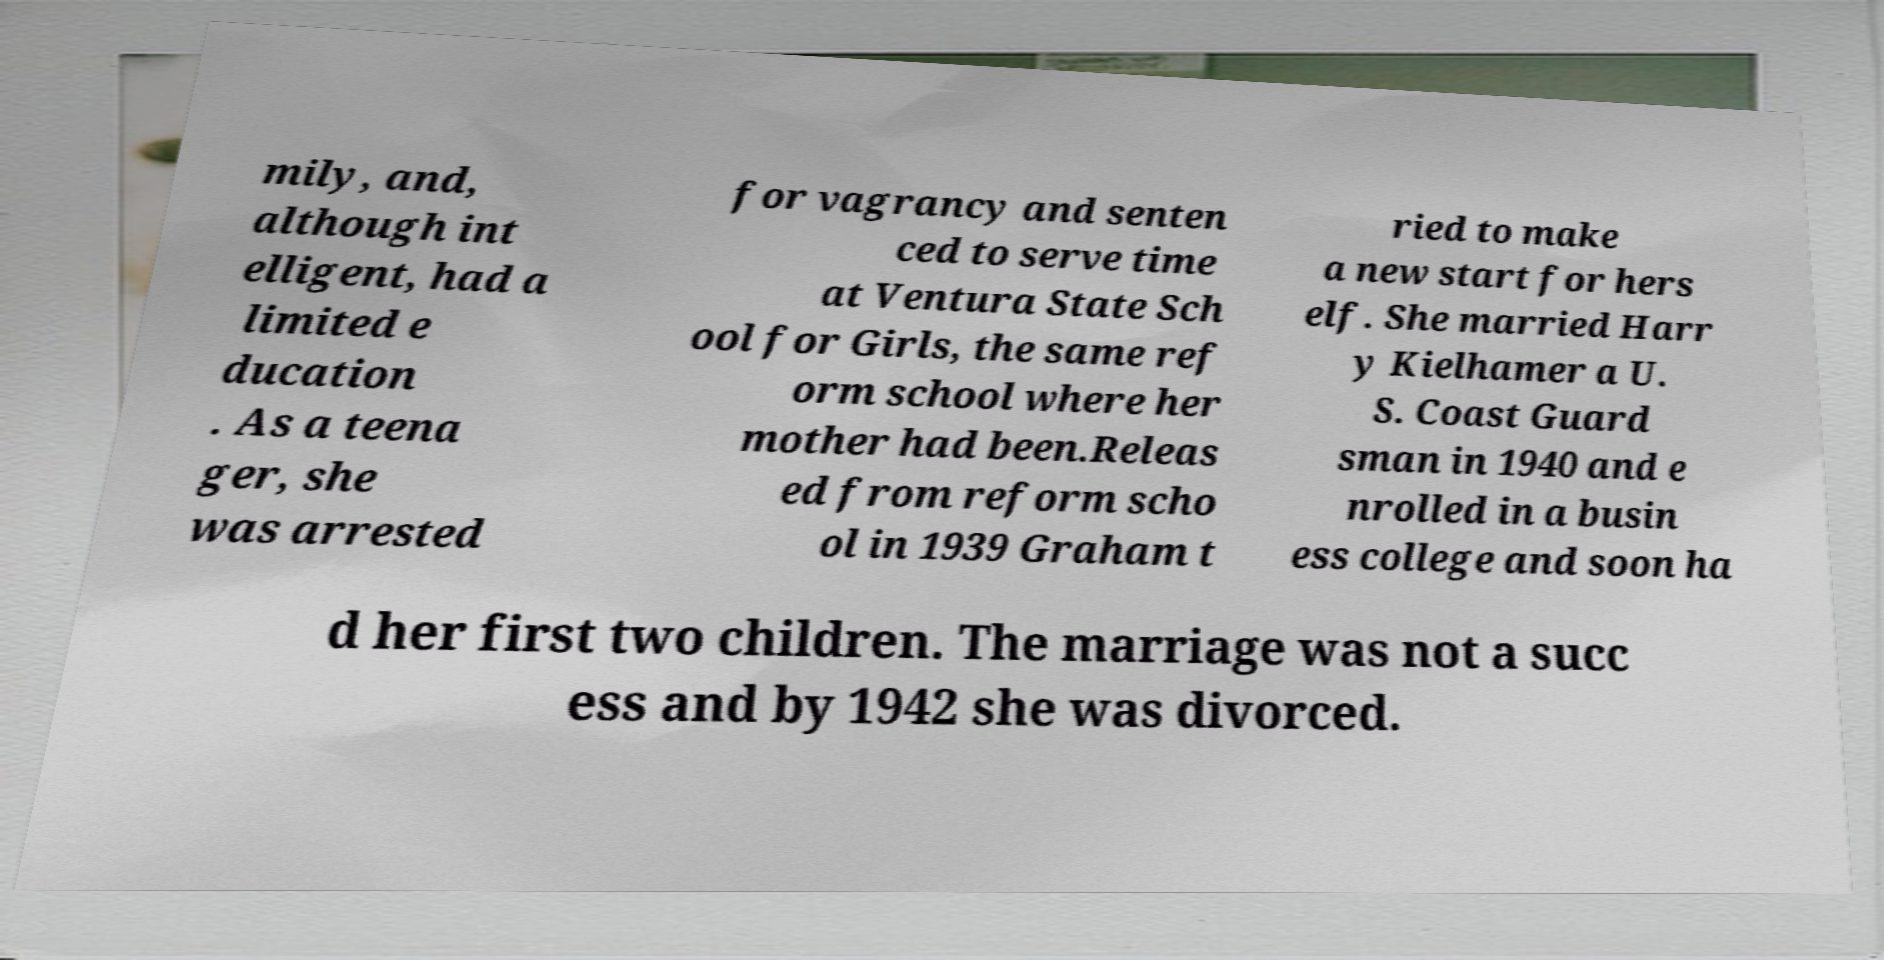Please identify and transcribe the text found in this image. mily, and, although int elligent, had a limited e ducation . As a teena ger, she was arrested for vagrancy and senten ced to serve time at Ventura State Sch ool for Girls, the same ref orm school where her mother had been.Releas ed from reform scho ol in 1939 Graham t ried to make a new start for hers elf. She married Harr y Kielhamer a U. S. Coast Guard sman in 1940 and e nrolled in a busin ess college and soon ha d her first two children. The marriage was not a succ ess and by 1942 she was divorced. 